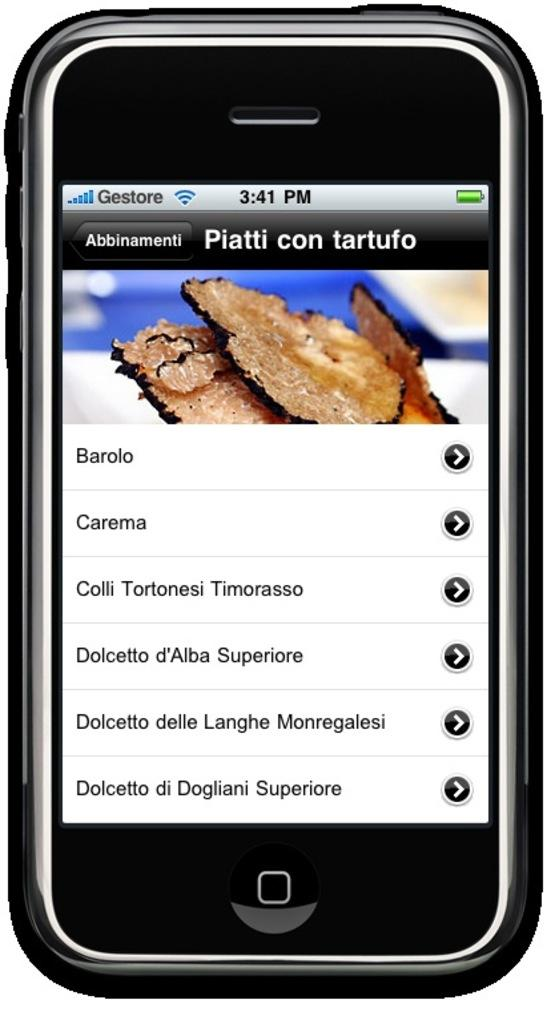<image>
Describe the image concisely. A black phone with the words Piatti con tartufo on its display. 